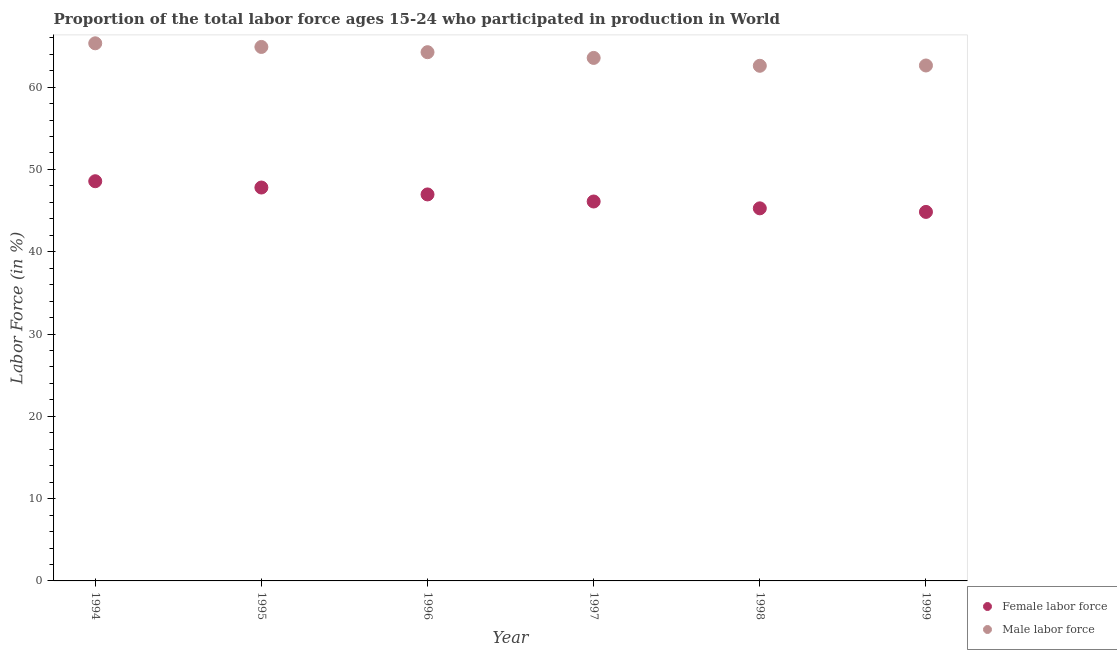Is the number of dotlines equal to the number of legend labels?
Make the answer very short. Yes. What is the percentage of female labor force in 1997?
Offer a terse response. 46.1. Across all years, what is the maximum percentage of male labour force?
Give a very brief answer. 65.32. Across all years, what is the minimum percentage of female labor force?
Provide a succinct answer. 44.84. In which year was the percentage of female labor force maximum?
Your answer should be compact. 1994. In which year was the percentage of female labor force minimum?
Offer a very short reply. 1999. What is the total percentage of male labour force in the graph?
Provide a short and direct response. 383.22. What is the difference between the percentage of female labor force in 1996 and that in 1999?
Provide a short and direct response. 2.12. What is the difference between the percentage of female labor force in 1997 and the percentage of male labour force in 1999?
Offer a very short reply. -16.53. What is the average percentage of female labor force per year?
Keep it short and to the point. 46.59. In the year 1995, what is the difference between the percentage of female labor force and percentage of male labour force?
Your answer should be very brief. -17.08. What is the ratio of the percentage of female labor force in 1994 to that in 1998?
Your answer should be compact. 1.07. Is the percentage of male labour force in 1994 less than that in 1996?
Your answer should be very brief. No. Is the difference between the percentage of male labour force in 1995 and 1996 greater than the difference between the percentage of female labor force in 1995 and 1996?
Provide a short and direct response. No. What is the difference between the highest and the second highest percentage of male labour force?
Offer a very short reply. 0.44. What is the difference between the highest and the lowest percentage of female labor force?
Offer a very short reply. 3.73. In how many years, is the percentage of male labour force greater than the average percentage of male labour force taken over all years?
Provide a short and direct response. 3. Is the sum of the percentage of female labor force in 1996 and 1999 greater than the maximum percentage of male labour force across all years?
Give a very brief answer. Yes. Is the percentage of female labor force strictly greater than the percentage of male labour force over the years?
Provide a short and direct response. No. Is the percentage of male labour force strictly less than the percentage of female labor force over the years?
Ensure brevity in your answer.  No. How many dotlines are there?
Your response must be concise. 2. What is the difference between two consecutive major ticks on the Y-axis?
Offer a very short reply. 10. Does the graph contain any zero values?
Make the answer very short. No. Does the graph contain grids?
Ensure brevity in your answer.  No. Where does the legend appear in the graph?
Ensure brevity in your answer.  Bottom right. How many legend labels are there?
Your response must be concise. 2. What is the title of the graph?
Provide a succinct answer. Proportion of the total labor force ages 15-24 who participated in production in World. What is the label or title of the X-axis?
Provide a succinct answer. Year. What is the label or title of the Y-axis?
Give a very brief answer. Labor Force (in %). What is the Labor Force (in %) of Female labor force in 1994?
Provide a short and direct response. 48.57. What is the Labor Force (in %) in Male labor force in 1994?
Your answer should be compact. 65.32. What is the Labor Force (in %) in Female labor force in 1995?
Keep it short and to the point. 47.8. What is the Labor Force (in %) in Male labor force in 1995?
Your answer should be very brief. 64.88. What is the Labor Force (in %) of Female labor force in 1996?
Your answer should be compact. 46.96. What is the Labor Force (in %) of Male labor force in 1996?
Provide a short and direct response. 64.24. What is the Labor Force (in %) of Female labor force in 1997?
Your answer should be very brief. 46.1. What is the Labor Force (in %) of Male labor force in 1997?
Make the answer very short. 63.55. What is the Labor Force (in %) in Female labor force in 1998?
Offer a terse response. 45.27. What is the Labor Force (in %) of Male labor force in 1998?
Provide a short and direct response. 62.59. What is the Labor Force (in %) of Female labor force in 1999?
Ensure brevity in your answer.  44.84. What is the Labor Force (in %) in Male labor force in 1999?
Ensure brevity in your answer.  62.63. Across all years, what is the maximum Labor Force (in %) of Female labor force?
Keep it short and to the point. 48.57. Across all years, what is the maximum Labor Force (in %) in Male labor force?
Your answer should be compact. 65.32. Across all years, what is the minimum Labor Force (in %) of Female labor force?
Your answer should be compact. 44.84. Across all years, what is the minimum Labor Force (in %) of Male labor force?
Your answer should be very brief. 62.59. What is the total Labor Force (in %) of Female labor force in the graph?
Ensure brevity in your answer.  279.54. What is the total Labor Force (in %) in Male labor force in the graph?
Give a very brief answer. 383.22. What is the difference between the Labor Force (in %) of Female labor force in 1994 and that in 1995?
Give a very brief answer. 0.76. What is the difference between the Labor Force (in %) of Male labor force in 1994 and that in 1995?
Your answer should be compact. 0.44. What is the difference between the Labor Force (in %) in Female labor force in 1994 and that in 1996?
Your answer should be very brief. 1.6. What is the difference between the Labor Force (in %) in Male labor force in 1994 and that in 1996?
Make the answer very short. 1.08. What is the difference between the Labor Force (in %) in Female labor force in 1994 and that in 1997?
Your answer should be compact. 2.46. What is the difference between the Labor Force (in %) in Male labor force in 1994 and that in 1997?
Your response must be concise. 1.78. What is the difference between the Labor Force (in %) in Female labor force in 1994 and that in 1998?
Ensure brevity in your answer.  3.29. What is the difference between the Labor Force (in %) of Male labor force in 1994 and that in 1998?
Give a very brief answer. 2.73. What is the difference between the Labor Force (in %) of Female labor force in 1994 and that in 1999?
Make the answer very short. 3.73. What is the difference between the Labor Force (in %) of Male labor force in 1994 and that in 1999?
Offer a very short reply. 2.7. What is the difference between the Labor Force (in %) of Female labor force in 1995 and that in 1996?
Your answer should be compact. 0.84. What is the difference between the Labor Force (in %) of Male labor force in 1995 and that in 1996?
Your answer should be compact. 0.64. What is the difference between the Labor Force (in %) in Female labor force in 1995 and that in 1997?
Make the answer very short. 1.7. What is the difference between the Labor Force (in %) of Male labor force in 1995 and that in 1997?
Keep it short and to the point. 1.33. What is the difference between the Labor Force (in %) in Female labor force in 1995 and that in 1998?
Offer a terse response. 2.53. What is the difference between the Labor Force (in %) of Male labor force in 1995 and that in 1998?
Your answer should be very brief. 2.29. What is the difference between the Labor Force (in %) of Female labor force in 1995 and that in 1999?
Keep it short and to the point. 2.96. What is the difference between the Labor Force (in %) of Male labor force in 1995 and that in 1999?
Provide a succinct answer. 2.25. What is the difference between the Labor Force (in %) of Female labor force in 1996 and that in 1997?
Offer a very short reply. 0.86. What is the difference between the Labor Force (in %) of Male labor force in 1996 and that in 1997?
Keep it short and to the point. 0.7. What is the difference between the Labor Force (in %) in Female labor force in 1996 and that in 1998?
Give a very brief answer. 1.69. What is the difference between the Labor Force (in %) in Male labor force in 1996 and that in 1998?
Your answer should be very brief. 1.65. What is the difference between the Labor Force (in %) in Female labor force in 1996 and that in 1999?
Give a very brief answer. 2.12. What is the difference between the Labor Force (in %) of Male labor force in 1996 and that in 1999?
Your answer should be very brief. 1.62. What is the difference between the Labor Force (in %) in Female labor force in 1997 and that in 1998?
Your answer should be very brief. 0.83. What is the difference between the Labor Force (in %) of Male labor force in 1997 and that in 1998?
Give a very brief answer. 0.96. What is the difference between the Labor Force (in %) of Female labor force in 1997 and that in 1999?
Give a very brief answer. 1.26. What is the difference between the Labor Force (in %) in Male labor force in 1997 and that in 1999?
Ensure brevity in your answer.  0.92. What is the difference between the Labor Force (in %) of Female labor force in 1998 and that in 1999?
Provide a succinct answer. 0.43. What is the difference between the Labor Force (in %) in Male labor force in 1998 and that in 1999?
Ensure brevity in your answer.  -0.04. What is the difference between the Labor Force (in %) of Female labor force in 1994 and the Labor Force (in %) of Male labor force in 1995?
Keep it short and to the point. -16.32. What is the difference between the Labor Force (in %) of Female labor force in 1994 and the Labor Force (in %) of Male labor force in 1996?
Provide a short and direct response. -15.68. What is the difference between the Labor Force (in %) in Female labor force in 1994 and the Labor Force (in %) in Male labor force in 1997?
Your response must be concise. -14.98. What is the difference between the Labor Force (in %) of Female labor force in 1994 and the Labor Force (in %) of Male labor force in 1998?
Offer a terse response. -14.03. What is the difference between the Labor Force (in %) in Female labor force in 1994 and the Labor Force (in %) in Male labor force in 1999?
Offer a very short reply. -14.06. What is the difference between the Labor Force (in %) of Female labor force in 1995 and the Labor Force (in %) of Male labor force in 1996?
Keep it short and to the point. -16.44. What is the difference between the Labor Force (in %) in Female labor force in 1995 and the Labor Force (in %) in Male labor force in 1997?
Provide a short and direct response. -15.75. What is the difference between the Labor Force (in %) of Female labor force in 1995 and the Labor Force (in %) of Male labor force in 1998?
Give a very brief answer. -14.79. What is the difference between the Labor Force (in %) in Female labor force in 1995 and the Labor Force (in %) in Male labor force in 1999?
Ensure brevity in your answer.  -14.83. What is the difference between the Labor Force (in %) of Female labor force in 1996 and the Labor Force (in %) of Male labor force in 1997?
Offer a terse response. -16.59. What is the difference between the Labor Force (in %) of Female labor force in 1996 and the Labor Force (in %) of Male labor force in 1998?
Ensure brevity in your answer.  -15.63. What is the difference between the Labor Force (in %) of Female labor force in 1996 and the Labor Force (in %) of Male labor force in 1999?
Give a very brief answer. -15.67. What is the difference between the Labor Force (in %) in Female labor force in 1997 and the Labor Force (in %) in Male labor force in 1998?
Offer a very short reply. -16.49. What is the difference between the Labor Force (in %) of Female labor force in 1997 and the Labor Force (in %) of Male labor force in 1999?
Make the answer very short. -16.53. What is the difference between the Labor Force (in %) in Female labor force in 1998 and the Labor Force (in %) in Male labor force in 1999?
Your response must be concise. -17.36. What is the average Labor Force (in %) in Female labor force per year?
Your answer should be compact. 46.59. What is the average Labor Force (in %) in Male labor force per year?
Provide a succinct answer. 63.87. In the year 1994, what is the difference between the Labor Force (in %) in Female labor force and Labor Force (in %) in Male labor force?
Your answer should be compact. -16.76. In the year 1995, what is the difference between the Labor Force (in %) in Female labor force and Labor Force (in %) in Male labor force?
Keep it short and to the point. -17.08. In the year 1996, what is the difference between the Labor Force (in %) of Female labor force and Labor Force (in %) of Male labor force?
Your answer should be very brief. -17.28. In the year 1997, what is the difference between the Labor Force (in %) in Female labor force and Labor Force (in %) in Male labor force?
Your response must be concise. -17.45. In the year 1998, what is the difference between the Labor Force (in %) of Female labor force and Labor Force (in %) of Male labor force?
Your answer should be very brief. -17.32. In the year 1999, what is the difference between the Labor Force (in %) in Female labor force and Labor Force (in %) in Male labor force?
Give a very brief answer. -17.79. What is the ratio of the Labor Force (in %) of Male labor force in 1994 to that in 1995?
Offer a terse response. 1.01. What is the ratio of the Labor Force (in %) in Female labor force in 1994 to that in 1996?
Provide a short and direct response. 1.03. What is the ratio of the Labor Force (in %) in Male labor force in 1994 to that in 1996?
Give a very brief answer. 1.02. What is the ratio of the Labor Force (in %) of Female labor force in 1994 to that in 1997?
Offer a terse response. 1.05. What is the ratio of the Labor Force (in %) of Male labor force in 1994 to that in 1997?
Offer a very short reply. 1.03. What is the ratio of the Labor Force (in %) in Female labor force in 1994 to that in 1998?
Make the answer very short. 1.07. What is the ratio of the Labor Force (in %) in Male labor force in 1994 to that in 1998?
Your answer should be very brief. 1.04. What is the ratio of the Labor Force (in %) in Female labor force in 1994 to that in 1999?
Make the answer very short. 1.08. What is the ratio of the Labor Force (in %) in Male labor force in 1994 to that in 1999?
Your response must be concise. 1.04. What is the ratio of the Labor Force (in %) of Female labor force in 1995 to that in 1996?
Keep it short and to the point. 1.02. What is the ratio of the Labor Force (in %) in Male labor force in 1995 to that in 1996?
Offer a terse response. 1.01. What is the ratio of the Labor Force (in %) of Female labor force in 1995 to that in 1997?
Offer a very short reply. 1.04. What is the ratio of the Labor Force (in %) in Male labor force in 1995 to that in 1997?
Keep it short and to the point. 1.02. What is the ratio of the Labor Force (in %) of Female labor force in 1995 to that in 1998?
Offer a very short reply. 1.06. What is the ratio of the Labor Force (in %) in Male labor force in 1995 to that in 1998?
Offer a very short reply. 1.04. What is the ratio of the Labor Force (in %) in Female labor force in 1995 to that in 1999?
Offer a very short reply. 1.07. What is the ratio of the Labor Force (in %) of Male labor force in 1995 to that in 1999?
Your answer should be very brief. 1.04. What is the ratio of the Labor Force (in %) of Female labor force in 1996 to that in 1997?
Offer a terse response. 1.02. What is the ratio of the Labor Force (in %) of Male labor force in 1996 to that in 1997?
Give a very brief answer. 1.01. What is the ratio of the Labor Force (in %) of Female labor force in 1996 to that in 1998?
Provide a short and direct response. 1.04. What is the ratio of the Labor Force (in %) of Male labor force in 1996 to that in 1998?
Your answer should be very brief. 1.03. What is the ratio of the Labor Force (in %) of Female labor force in 1996 to that in 1999?
Ensure brevity in your answer.  1.05. What is the ratio of the Labor Force (in %) of Male labor force in 1996 to that in 1999?
Your answer should be compact. 1.03. What is the ratio of the Labor Force (in %) in Female labor force in 1997 to that in 1998?
Provide a succinct answer. 1.02. What is the ratio of the Labor Force (in %) in Male labor force in 1997 to that in 1998?
Keep it short and to the point. 1.02. What is the ratio of the Labor Force (in %) of Female labor force in 1997 to that in 1999?
Keep it short and to the point. 1.03. What is the ratio of the Labor Force (in %) of Male labor force in 1997 to that in 1999?
Your answer should be compact. 1.01. What is the ratio of the Labor Force (in %) in Female labor force in 1998 to that in 1999?
Your response must be concise. 1.01. What is the ratio of the Labor Force (in %) of Male labor force in 1998 to that in 1999?
Keep it short and to the point. 1. What is the difference between the highest and the second highest Labor Force (in %) in Female labor force?
Your response must be concise. 0.76. What is the difference between the highest and the second highest Labor Force (in %) in Male labor force?
Your answer should be compact. 0.44. What is the difference between the highest and the lowest Labor Force (in %) of Female labor force?
Offer a terse response. 3.73. What is the difference between the highest and the lowest Labor Force (in %) of Male labor force?
Provide a short and direct response. 2.73. 